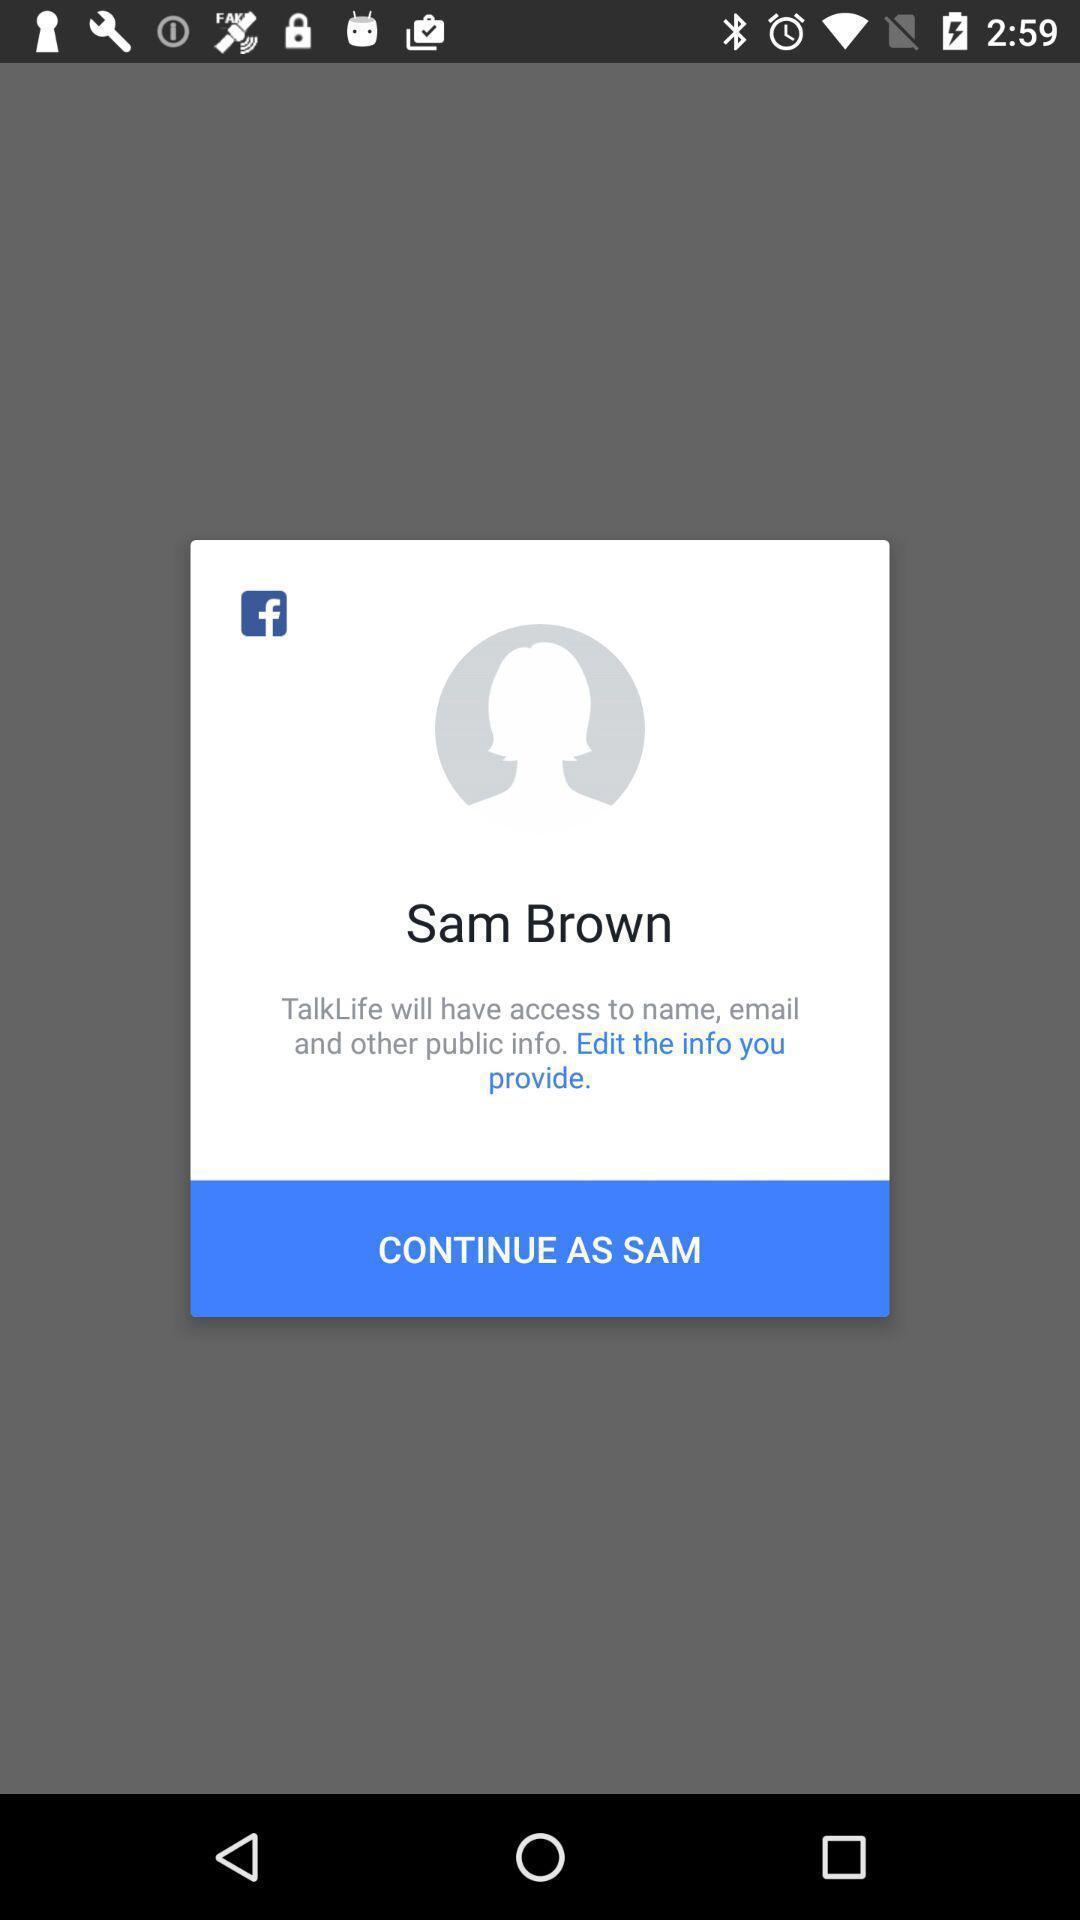Summarize the information in this screenshot. Pop-up asking for permission to allow access to personal data. 